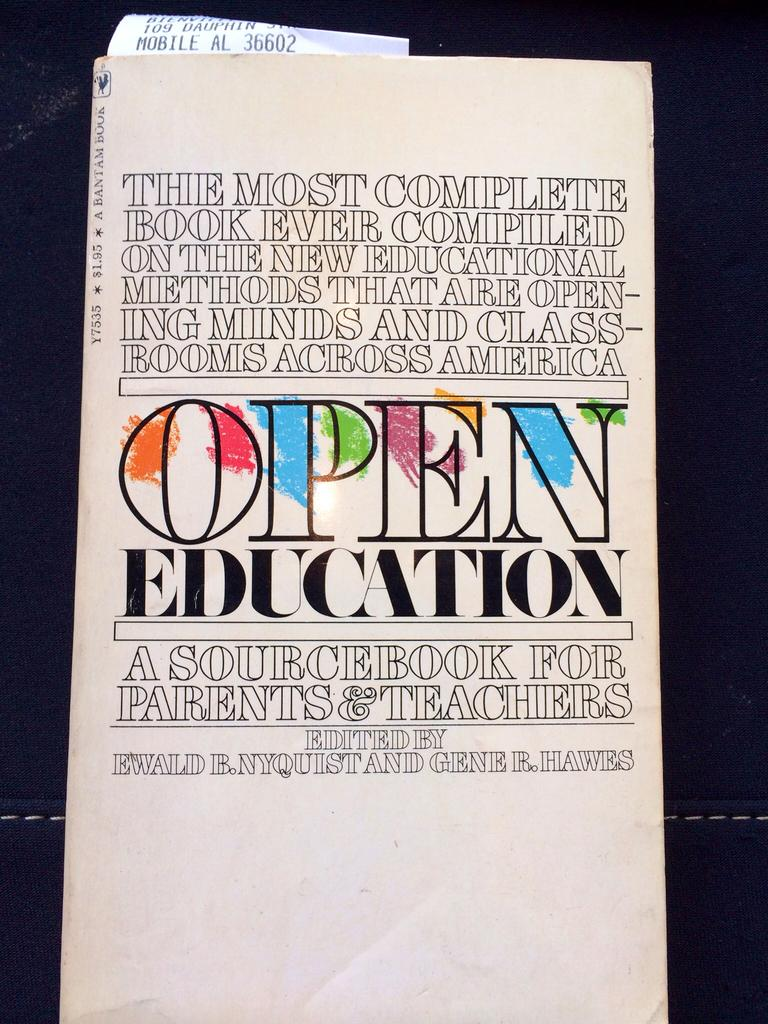<image>
Write a terse but informative summary of the picture. An book called Open Education, a sourcebook for parents and teachers. 